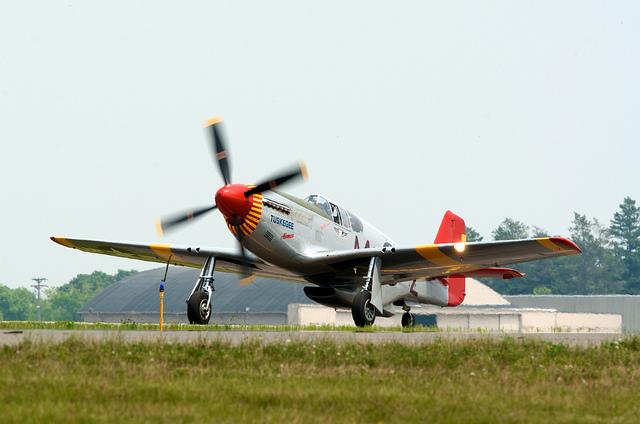What is in motion?
Answer briefly. Plane. What color is the tip of the plane?
Write a very short answer. Red. Are there telephone poles?
Keep it brief. No. 